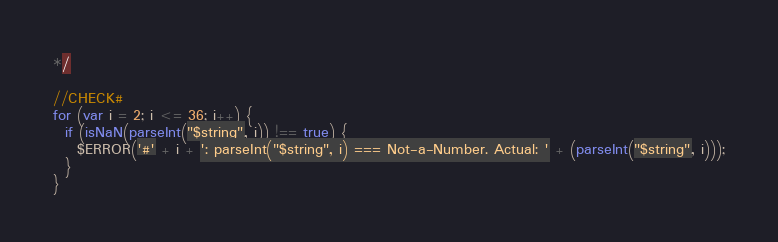Convert code to text. <code><loc_0><loc_0><loc_500><loc_500><_JavaScript_>*/

//CHECK#
for (var i = 2; i <= 36; i++) {
  if (isNaN(parseInt("$string", i)) !== true) {
    $ERROR('#' + i + ': parseInt("$string", i) === Not-a-Number. Actual: ' + (parseInt("$string", i)));
  }
}    
</code> 